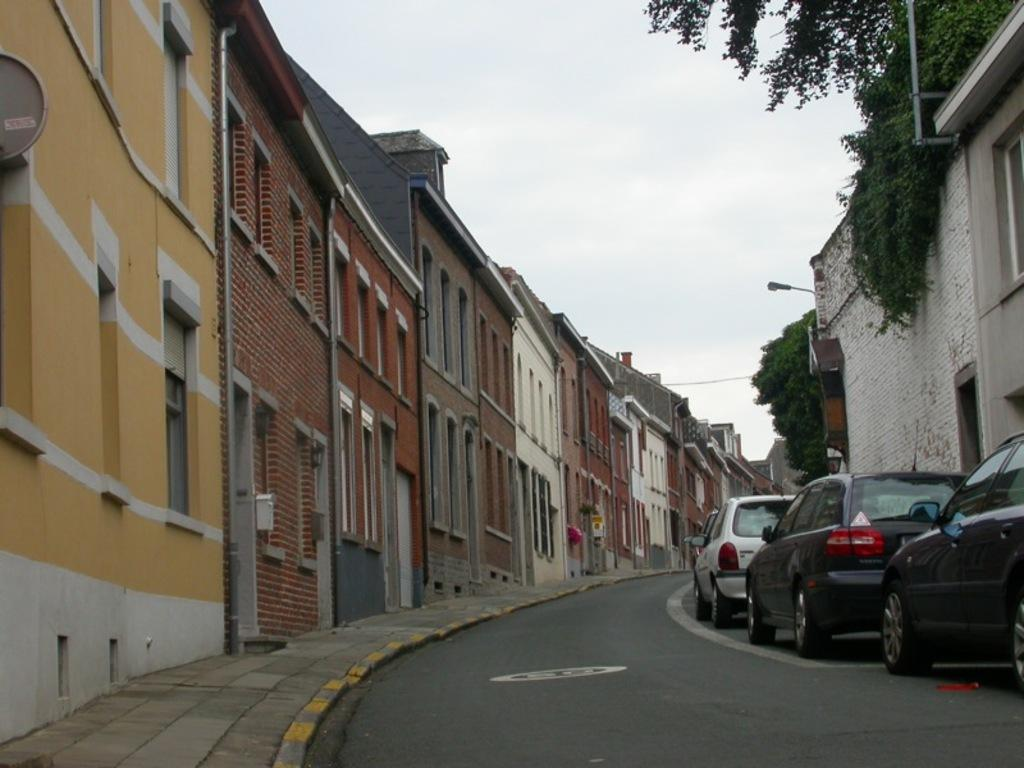What type of structures can be seen in the image? There are buildings in the image. What other natural elements are visible in the image? There are trees in the image. What feature can be found on the buildings and possibly other objects in the image? There are windows in the image. What mode of transportation can be seen on the road in the image? Vehicles are present on the road in the image. What type of shoe is causing trouble on the road in the image? There is no shoe present in the image, let alone one causing trouble. 